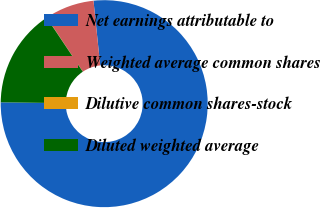<chart> <loc_0><loc_0><loc_500><loc_500><pie_chart><fcel>Net earnings attributable to<fcel>Weighted average common shares<fcel>Dilutive common shares-stock<fcel>Diluted weighted average<nl><fcel>76.86%<fcel>7.71%<fcel>0.03%<fcel>15.4%<nl></chart> 